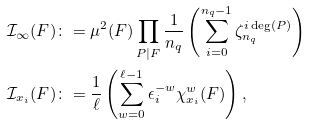Convert formula to latex. <formula><loc_0><loc_0><loc_500><loc_500>\mathcal { I } _ { \infty } ( F ) & \colon = \mu ^ { 2 } ( F ) \prod _ { P | F } \frac { 1 } { n _ { q } } \left ( \sum _ { i = 0 } ^ { n _ { q } - 1 } \zeta _ { n _ { q } } ^ { i \deg ( P ) } \right ) \\ \mathcal { I } _ { x _ { i } } ( F ) & \colon = \frac { 1 } { \ell } \left ( \sum _ { w = 0 } ^ { \ell - 1 } \epsilon _ { i } ^ { - w } \chi _ { x _ { i } } ^ { w } ( F ) \right ) ,</formula> 